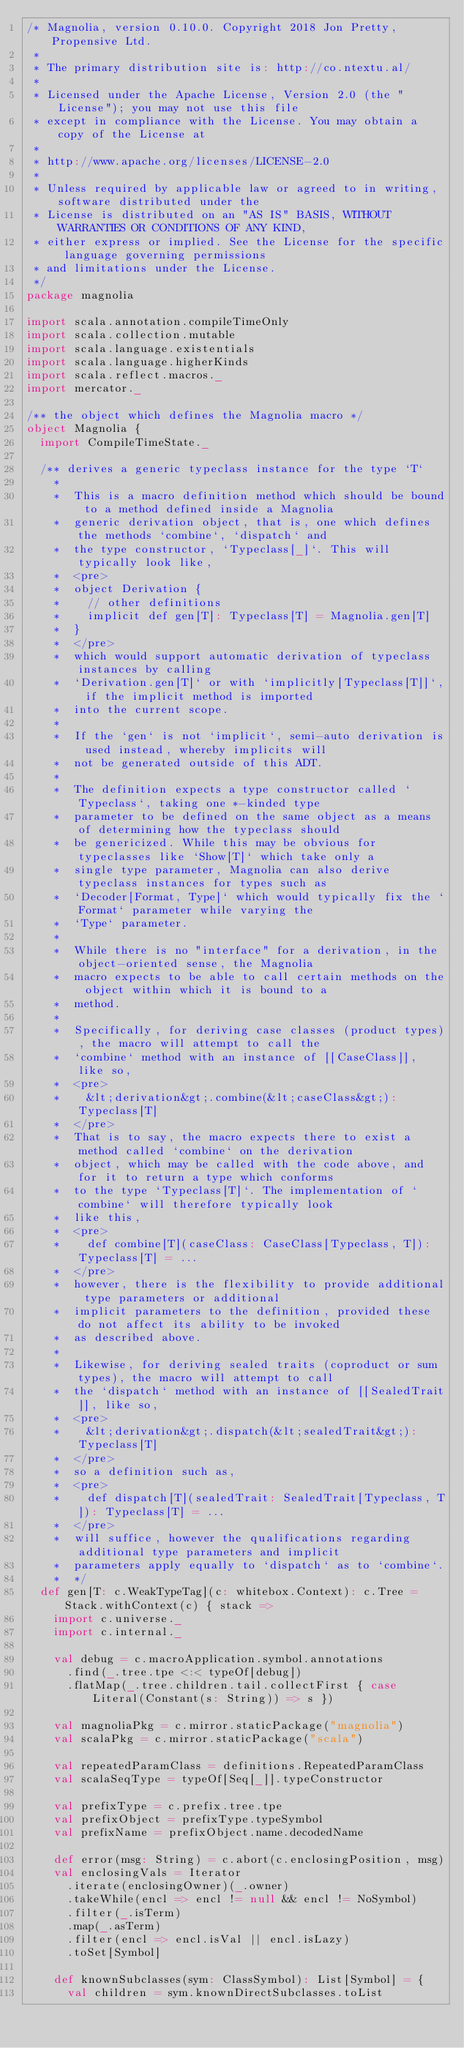<code> <loc_0><loc_0><loc_500><loc_500><_Scala_>/* Magnolia, version 0.10.0. Copyright 2018 Jon Pretty, Propensive Ltd.
 *
 * The primary distribution site is: http://co.ntextu.al/
 *
 * Licensed under the Apache License, Version 2.0 (the "License"); you may not use this file
 * except in compliance with the License. You may obtain a copy of the License at
 *
 * http://www.apache.org/licenses/LICENSE-2.0
 *
 * Unless required by applicable law or agreed to in writing, software distributed under the
 * License is distributed on an "AS IS" BASIS, WITHOUT WARRANTIES OR CONDITIONS OF ANY KIND,
 * either express or implied. See the License for the specific language governing permissions
 * and limitations under the License.
 */
package magnolia

import scala.annotation.compileTimeOnly
import scala.collection.mutable
import scala.language.existentials
import scala.language.higherKinds
import scala.reflect.macros._
import mercator._

/** the object which defines the Magnolia macro */
object Magnolia {
  import CompileTimeState._

  /** derives a generic typeclass instance for the type `T`
    *
    *  This is a macro definition method which should be bound to a method defined inside a Magnolia
    *  generic derivation object, that is, one which defines the methods `combine`, `dispatch` and
    *  the type constructor, `Typeclass[_]`. This will typically look like,
    *  <pre>
    *  object Derivation {
    *    // other definitions
    *    implicit def gen[T]: Typeclass[T] = Magnolia.gen[T]
    *  }
    *  </pre>
    *  which would support automatic derivation of typeclass instances by calling
    *  `Derivation.gen[T]` or with `implicitly[Typeclass[T]]`, if the implicit method is imported
    *  into the current scope.
    *
    *  If the `gen` is not `implicit`, semi-auto derivation is used instead, whereby implicits will
    *  not be generated outside of this ADT.
    *
    *  The definition expects a type constructor called `Typeclass`, taking one *-kinded type
    *  parameter to be defined on the same object as a means of determining how the typeclass should
    *  be genericized. While this may be obvious for typeclasses like `Show[T]` which take only a
    *  single type parameter, Magnolia can also derive typeclass instances for types such as
    *  `Decoder[Format, Type]` which would typically fix the `Format` parameter while varying the
    *  `Type` parameter.
    *
    *  While there is no "interface" for a derivation, in the object-oriented sense, the Magnolia
    *  macro expects to be able to call certain methods on the object within which it is bound to a
    *  method.
    *
    *  Specifically, for deriving case classes (product types), the macro will attempt to call the
    *  `combine` method with an instance of [[CaseClass]], like so,
    *  <pre>
    *    &lt;derivation&gt;.combine(&lt;caseClass&gt;): Typeclass[T]
    *  </pre>
    *  That is to say, the macro expects there to exist a method called `combine` on the derivation
    *  object, which may be called with the code above, and for it to return a type which conforms
    *  to the type `Typeclass[T]`. The implementation of `combine` will therefore typically look
    *  like this,
    *  <pre>
    *    def combine[T](caseClass: CaseClass[Typeclass, T]): Typeclass[T] = ...
    *  </pre>
    *  however, there is the flexibility to provide additional type parameters or additional
    *  implicit parameters to the definition, provided these do not affect its ability to be invoked
    *  as described above.
    *
    *  Likewise, for deriving sealed traits (coproduct or sum types), the macro will attempt to call
    *  the `dispatch` method with an instance of [[SealedTrait]], like so,
    *  <pre>
    *    &lt;derivation&gt;.dispatch(&lt;sealedTrait&gt;): Typeclass[T]
    *  </pre>
    *  so a definition such as,
    *  <pre>
    *    def dispatch[T](sealedTrait: SealedTrait[Typeclass, T]): Typeclass[T] = ...
    *  </pre>
    *  will suffice, however the qualifications regarding additional type parameters and implicit
    *  parameters apply equally to `dispatch` as to `combine`.
    *  */
  def gen[T: c.WeakTypeTag](c: whitebox.Context): c.Tree = Stack.withContext(c) { stack =>
    import c.universe._
    import c.internal._

    val debug = c.macroApplication.symbol.annotations
      .find(_.tree.tpe <:< typeOf[debug])
      .flatMap(_.tree.children.tail.collectFirst { case Literal(Constant(s: String)) => s })

    val magnoliaPkg = c.mirror.staticPackage("magnolia")
    val scalaPkg = c.mirror.staticPackage("scala")

    val repeatedParamClass = definitions.RepeatedParamClass
    val scalaSeqType = typeOf[Seq[_]].typeConstructor

    val prefixType = c.prefix.tree.tpe
    val prefixObject = prefixType.typeSymbol
    val prefixName = prefixObject.name.decodedName

    def error(msg: String) = c.abort(c.enclosingPosition, msg)
    val enclosingVals = Iterator
      .iterate(enclosingOwner)(_.owner)
      .takeWhile(encl => encl != null && encl != NoSymbol)
      .filter(_.isTerm)
      .map(_.asTerm)
      .filter(encl => encl.isVal || encl.isLazy)
      .toSet[Symbol]

    def knownSubclasses(sym: ClassSymbol): List[Symbol] = {
      val children = sym.knownDirectSubclasses.toList</code> 